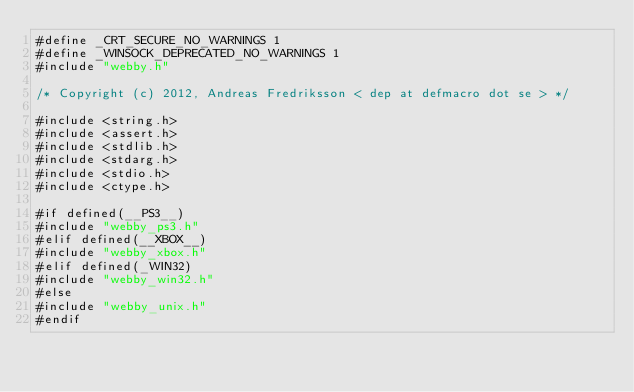Convert code to text. <code><loc_0><loc_0><loc_500><loc_500><_C_>#define _CRT_SECURE_NO_WARNINGS 1
#define _WINSOCK_DEPRECATED_NO_WARNINGS 1
#include "webby.h"

/* Copyright (c) 2012, Andreas Fredriksson < dep at defmacro dot se > */

#include <string.h>
#include <assert.h>
#include <stdlib.h>
#include <stdarg.h>
#include <stdio.h>
#include <ctype.h>

#if defined(__PS3__)
#include "webby_ps3.h"
#elif defined(__XBOX__)
#include "webby_xbox.h"
#elif defined(_WIN32)
#include "webby_win32.h"
#else
#include "webby_unix.h"
#endif
</code> 